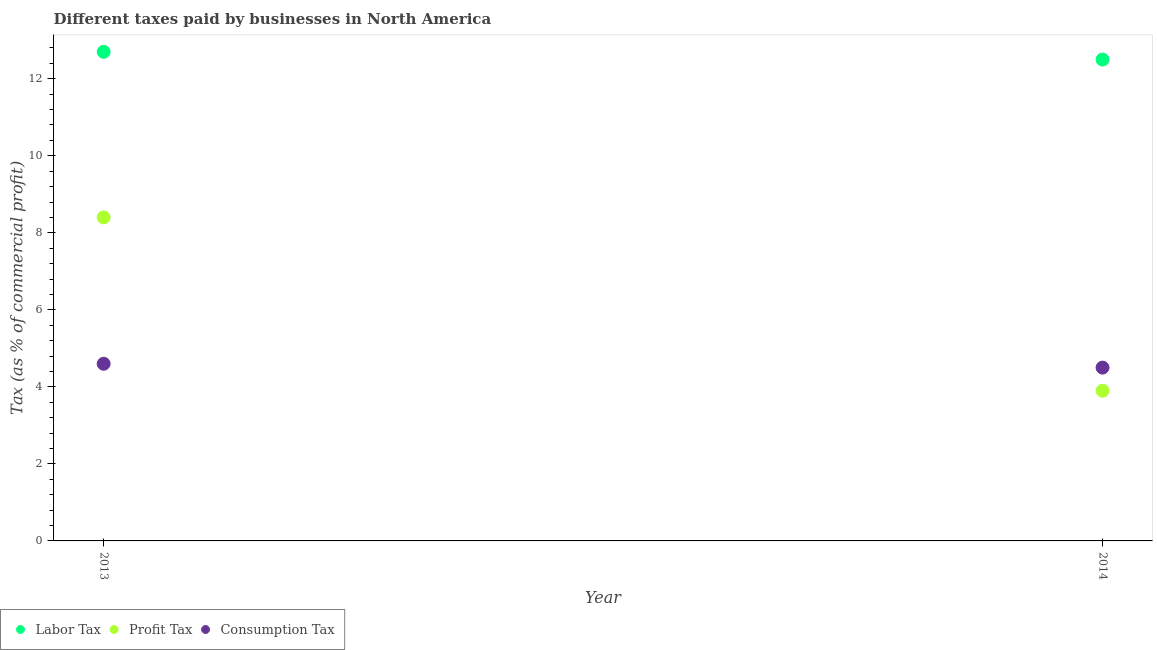How many different coloured dotlines are there?
Make the answer very short. 3. Across all years, what is the maximum percentage of profit tax?
Give a very brief answer. 8.4. Across all years, what is the minimum percentage of consumption tax?
Give a very brief answer. 4.5. In which year was the percentage of labor tax maximum?
Your answer should be very brief. 2013. What is the total percentage of consumption tax in the graph?
Offer a terse response. 9.1. What is the difference between the percentage of labor tax in 2013 and that in 2014?
Offer a very short reply. 0.2. What is the difference between the percentage of consumption tax in 2014 and the percentage of labor tax in 2013?
Your answer should be compact. -8.2. In the year 2013, what is the difference between the percentage of profit tax and percentage of consumption tax?
Provide a succinct answer. 3.8. In how many years, is the percentage of profit tax greater than 4.8 %?
Your answer should be compact. 1. What is the ratio of the percentage of consumption tax in 2013 to that in 2014?
Provide a succinct answer. 1.02. Is the percentage of labor tax in 2013 less than that in 2014?
Your response must be concise. No. Is it the case that in every year, the sum of the percentage of labor tax and percentage of profit tax is greater than the percentage of consumption tax?
Your answer should be compact. Yes. Is the percentage of profit tax strictly greater than the percentage of consumption tax over the years?
Make the answer very short. No. How many years are there in the graph?
Give a very brief answer. 2. What is the difference between two consecutive major ticks on the Y-axis?
Offer a very short reply. 2. Are the values on the major ticks of Y-axis written in scientific E-notation?
Offer a terse response. No. Does the graph contain any zero values?
Provide a succinct answer. No. Where does the legend appear in the graph?
Your response must be concise. Bottom left. How many legend labels are there?
Ensure brevity in your answer.  3. How are the legend labels stacked?
Keep it short and to the point. Horizontal. What is the title of the graph?
Ensure brevity in your answer.  Different taxes paid by businesses in North America. What is the label or title of the X-axis?
Keep it short and to the point. Year. What is the label or title of the Y-axis?
Provide a succinct answer. Tax (as % of commercial profit). What is the Tax (as % of commercial profit) of Consumption Tax in 2013?
Your answer should be compact. 4.6. What is the Tax (as % of commercial profit) in Profit Tax in 2014?
Ensure brevity in your answer.  3.9. What is the Tax (as % of commercial profit) in Consumption Tax in 2014?
Provide a short and direct response. 4.5. Across all years, what is the maximum Tax (as % of commercial profit) in Profit Tax?
Your answer should be compact. 8.4. Across all years, what is the maximum Tax (as % of commercial profit) in Consumption Tax?
Make the answer very short. 4.6. Across all years, what is the minimum Tax (as % of commercial profit) in Consumption Tax?
Keep it short and to the point. 4.5. What is the total Tax (as % of commercial profit) of Labor Tax in the graph?
Provide a short and direct response. 25.2. What is the total Tax (as % of commercial profit) in Profit Tax in the graph?
Your response must be concise. 12.3. What is the difference between the Tax (as % of commercial profit) in Labor Tax in 2013 and that in 2014?
Your answer should be compact. 0.2. What is the difference between the Tax (as % of commercial profit) of Profit Tax in 2013 and that in 2014?
Provide a succinct answer. 4.5. What is the difference between the Tax (as % of commercial profit) in Labor Tax in 2013 and the Tax (as % of commercial profit) in Consumption Tax in 2014?
Your response must be concise. 8.2. What is the average Tax (as % of commercial profit) of Profit Tax per year?
Provide a succinct answer. 6.15. What is the average Tax (as % of commercial profit) of Consumption Tax per year?
Your answer should be very brief. 4.55. In the year 2013, what is the difference between the Tax (as % of commercial profit) of Profit Tax and Tax (as % of commercial profit) of Consumption Tax?
Provide a short and direct response. 3.8. In the year 2014, what is the difference between the Tax (as % of commercial profit) in Profit Tax and Tax (as % of commercial profit) in Consumption Tax?
Make the answer very short. -0.6. What is the ratio of the Tax (as % of commercial profit) in Profit Tax in 2013 to that in 2014?
Provide a short and direct response. 2.15. What is the ratio of the Tax (as % of commercial profit) in Consumption Tax in 2013 to that in 2014?
Ensure brevity in your answer.  1.02. What is the difference between the highest and the second highest Tax (as % of commercial profit) in Profit Tax?
Offer a very short reply. 4.5. What is the difference between the highest and the second highest Tax (as % of commercial profit) of Consumption Tax?
Ensure brevity in your answer.  0.1. What is the difference between the highest and the lowest Tax (as % of commercial profit) of Labor Tax?
Your answer should be compact. 0.2. What is the difference between the highest and the lowest Tax (as % of commercial profit) of Profit Tax?
Offer a terse response. 4.5. What is the difference between the highest and the lowest Tax (as % of commercial profit) in Consumption Tax?
Make the answer very short. 0.1. 